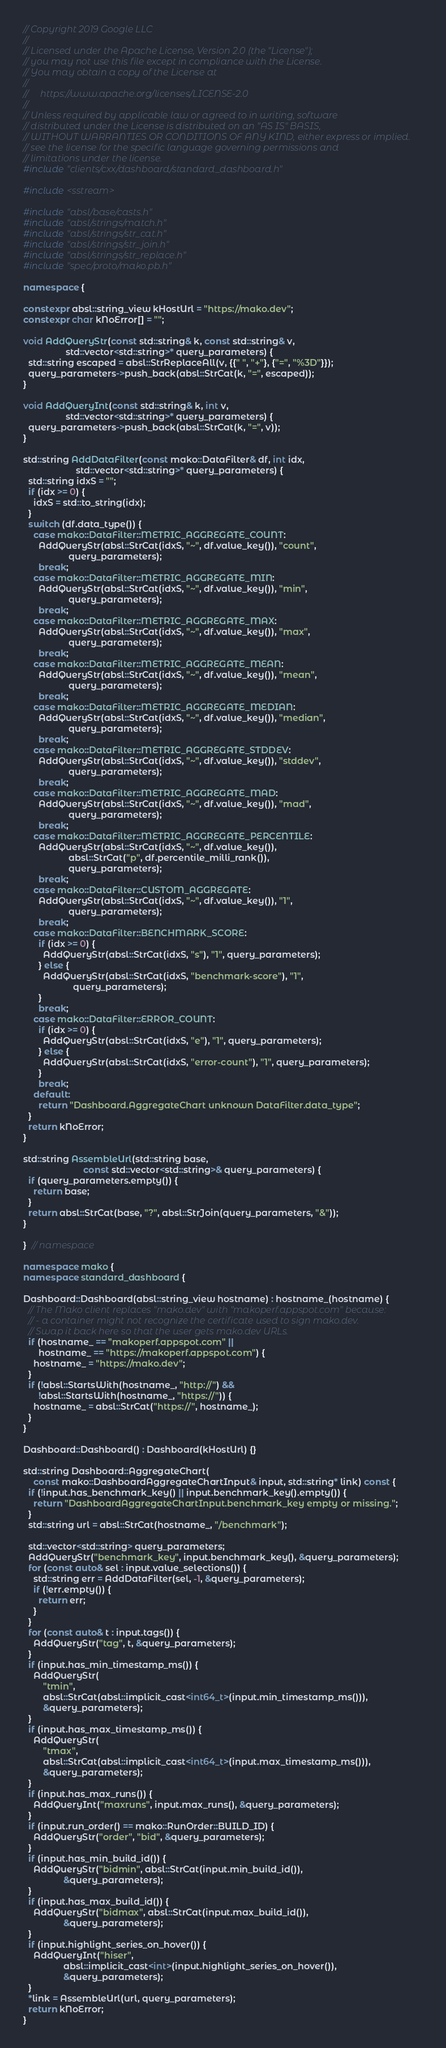<code> <loc_0><loc_0><loc_500><loc_500><_C++_>// Copyright 2019 Google LLC
//
// Licensed under the Apache License, Version 2.0 (the "License");
// you may not use this file except in compliance with the License.
// You may obtain a copy of the License at
//
//     https://www.apache.org/licenses/LICENSE-2.0
//
// Unless required by applicable law or agreed to in writing, software
// distributed under the License is distributed on an "AS IS" BASIS,
// WITHOUT WARRANTIES OR CONDITIONS OF ANY KIND, either express or implied.
// see the license for the specific language governing permissions and
// limitations under the license.
#include "clients/cxx/dashboard/standard_dashboard.h"

#include <sstream>

#include "absl/base/casts.h"
#include "absl/strings/match.h"
#include "absl/strings/str_cat.h"
#include "absl/strings/str_join.h"
#include "absl/strings/str_replace.h"
#include "spec/proto/mako.pb.h"

namespace {

constexpr absl::string_view kHostUrl = "https://mako.dev";
constexpr char kNoError[] = "";

void AddQueryStr(const std::string& k, const std::string& v,
                 std::vector<std::string>* query_parameters) {
  std::string escaped = absl::StrReplaceAll(v, {{" ", "+"}, {"=", "%3D"}});
  query_parameters->push_back(absl::StrCat(k, "=", escaped));
}

void AddQueryInt(const std::string& k, int v,
                 std::vector<std::string>* query_parameters) {
  query_parameters->push_back(absl::StrCat(k, "=", v));
}

std::string AddDataFilter(const mako::DataFilter& df, int idx,
                     std::vector<std::string>* query_parameters) {
  std::string idxS = "";
  if (idx >= 0) {
    idxS = std::to_string(idx);
  }
  switch (df.data_type()) {
    case mako::DataFilter::METRIC_AGGREGATE_COUNT:
      AddQueryStr(absl::StrCat(idxS, "~", df.value_key()), "count",
                  query_parameters);
      break;
    case mako::DataFilter::METRIC_AGGREGATE_MIN:
      AddQueryStr(absl::StrCat(idxS, "~", df.value_key()), "min",
                  query_parameters);
      break;
    case mako::DataFilter::METRIC_AGGREGATE_MAX:
      AddQueryStr(absl::StrCat(idxS, "~", df.value_key()), "max",
                  query_parameters);
      break;
    case mako::DataFilter::METRIC_AGGREGATE_MEAN:
      AddQueryStr(absl::StrCat(idxS, "~", df.value_key()), "mean",
                  query_parameters);
      break;
    case mako::DataFilter::METRIC_AGGREGATE_MEDIAN:
      AddQueryStr(absl::StrCat(idxS, "~", df.value_key()), "median",
                  query_parameters);
      break;
    case mako::DataFilter::METRIC_AGGREGATE_STDDEV:
      AddQueryStr(absl::StrCat(idxS, "~", df.value_key()), "stddev",
                  query_parameters);
      break;
    case mako::DataFilter::METRIC_AGGREGATE_MAD:
      AddQueryStr(absl::StrCat(idxS, "~", df.value_key()), "mad",
                  query_parameters);
      break;
    case mako::DataFilter::METRIC_AGGREGATE_PERCENTILE:
      AddQueryStr(absl::StrCat(idxS, "~", df.value_key()),
                  absl::StrCat("p", df.percentile_milli_rank()),
                  query_parameters);
      break;
    case mako::DataFilter::CUSTOM_AGGREGATE:
      AddQueryStr(absl::StrCat(idxS, "~", df.value_key()), "1",
                  query_parameters);
      break;
    case mako::DataFilter::BENCHMARK_SCORE:
      if (idx >= 0) {
        AddQueryStr(absl::StrCat(idxS, "s"), "1", query_parameters);
      } else {
        AddQueryStr(absl::StrCat(idxS, "benchmark-score"), "1",
                    query_parameters);
      }
      break;
    case mako::DataFilter::ERROR_COUNT:
      if (idx >= 0) {
        AddQueryStr(absl::StrCat(idxS, "e"), "1", query_parameters);
      } else {
        AddQueryStr(absl::StrCat(idxS, "error-count"), "1", query_parameters);
      }
      break;
    default:
      return "Dashboard.AggregateChart unknown DataFilter.data_type";
  }
  return kNoError;
}

std::string AssembleUrl(std::string base,
                        const std::vector<std::string>& query_parameters) {
  if (query_parameters.empty()) {
    return base;
  }
  return absl::StrCat(base, "?", absl::StrJoin(query_parameters, "&"));
}

}  // namespace

namespace mako {
namespace standard_dashboard {

Dashboard::Dashboard(absl::string_view hostname) : hostname_(hostname) {
  // The Mako client replaces "mako.dev" with "makoperf.appspot.com" because:
  // - a container might not recognize the certificate used to sign mako.dev.
  // Swap it back here so that the user gets mako.dev URLs.
  if (hostname_ == "makoperf.appspot.com" ||
      hostname_ == "https://makoperf.appspot.com") {
    hostname_ = "https://mako.dev";
  }
  if (!absl::StartsWith(hostname_, "http://") &&
      !absl::StartsWith(hostname_, "https://")) {
    hostname_ = absl::StrCat("https://", hostname_);
  }
}

Dashboard::Dashboard() : Dashboard(kHostUrl) {}

std::string Dashboard::AggregateChart(
    const mako::DashboardAggregateChartInput& input, std::string* link) const {
  if (!input.has_benchmark_key() || input.benchmark_key().empty()) {
    return "DashboardAggregateChartInput.benchmark_key empty or missing.";
  }
  std::string url = absl::StrCat(hostname_, "/benchmark");

  std::vector<std::string> query_parameters;
  AddQueryStr("benchmark_key", input.benchmark_key(), &query_parameters);
  for (const auto& sel : input.value_selections()) {
    std::string err = AddDataFilter(sel, -1, &query_parameters);
    if (!err.empty()) {
      return err;
    }
  }
  for (const auto& t : input.tags()) {
    AddQueryStr("tag", t, &query_parameters);
  }
  if (input.has_min_timestamp_ms()) {
    AddQueryStr(
        "tmin",
        absl::StrCat(absl::implicit_cast<int64_t>(input.min_timestamp_ms())),
        &query_parameters);
  }
  if (input.has_max_timestamp_ms()) {
    AddQueryStr(
        "tmax",
        absl::StrCat(absl::implicit_cast<int64_t>(input.max_timestamp_ms())),
        &query_parameters);
  }
  if (input.has_max_runs()) {
    AddQueryInt("maxruns", input.max_runs(), &query_parameters);
  }
  if (input.run_order() == mako::RunOrder::BUILD_ID) {
    AddQueryStr("order", "bid", &query_parameters);
  }
  if (input.has_min_build_id()) {
    AddQueryStr("bidmin", absl::StrCat(input.min_build_id()),
                &query_parameters);
  }
  if (input.has_max_build_id()) {
    AddQueryStr("bidmax", absl::StrCat(input.max_build_id()),
                &query_parameters);
  }
  if (input.highlight_series_on_hover()) {
    AddQueryInt("hiser",
                absl::implicit_cast<int>(input.highlight_series_on_hover()),
                &query_parameters);
  }
  *link = AssembleUrl(url, query_parameters);
  return kNoError;
}
</code> 